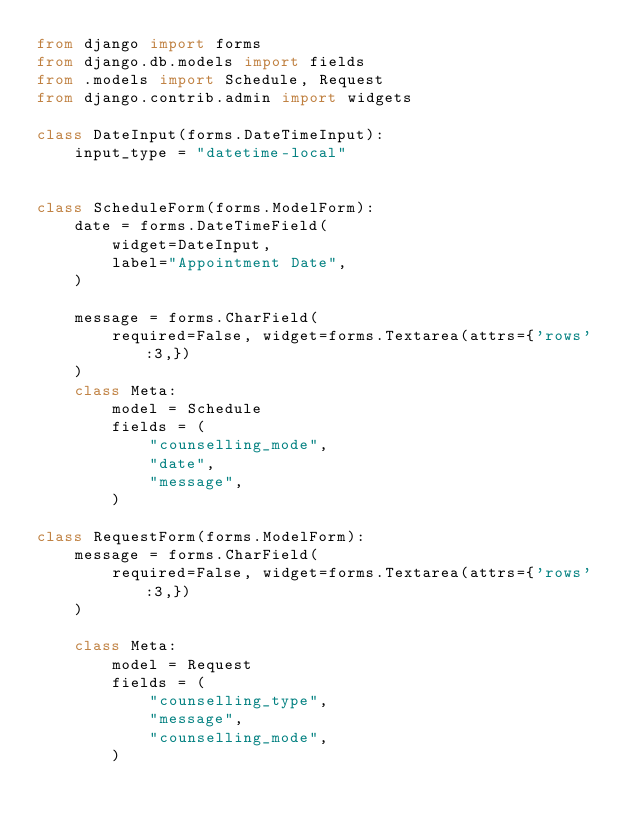Convert code to text. <code><loc_0><loc_0><loc_500><loc_500><_Python_>from django import forms
from django.db.models import fields
from .models import Schedule, Request
from django.contrib.admin import widgets

class DateInput(forms.DateTimeInput):
    input_type = "datetime-local"


class ScheduleForm(forms.ModelForm):
    date = forms.DateTimeField(
        widget=DateInput,
        label="Appointment Date",
    )

    message = forms.CharField(
        required=False, widget=forms.Textarea(attrs={'rows':3,})
    )
    class Meta:
        model = Schedule
        fields = (
            "counselling_mode",
            "date",
            "message",
        )

class RequestForm(forms.ModelForm):
    message = forms.CharField(
        required=False, widget=forms.Textarea(attrs={'rows':3,})
    )
    
    class Meta:
        model = Request
        fields = (
            "counselling_type",
            "message",
            "counselling_mode",
        )</code> 